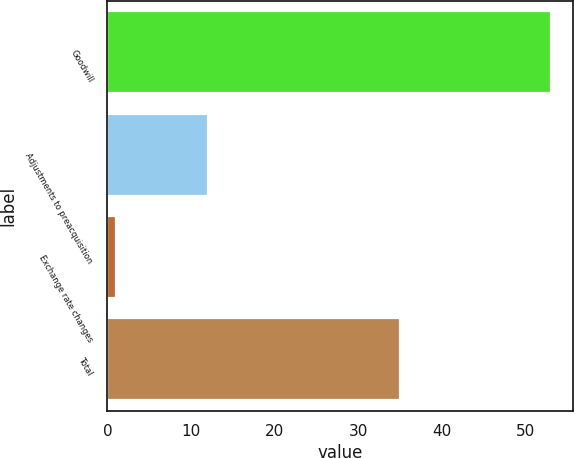Convert chart to OTSL. <chart><loc_0><loc_0><loc_500><loc_500><bar_chart><fcel>Goodwill<fcel>Adjustments to preacquisition<fcel>Exchange rate changes<fcel>Total<nl><fcel>53<fcel>12<fcel>1<fcel>35<nl></chart> 